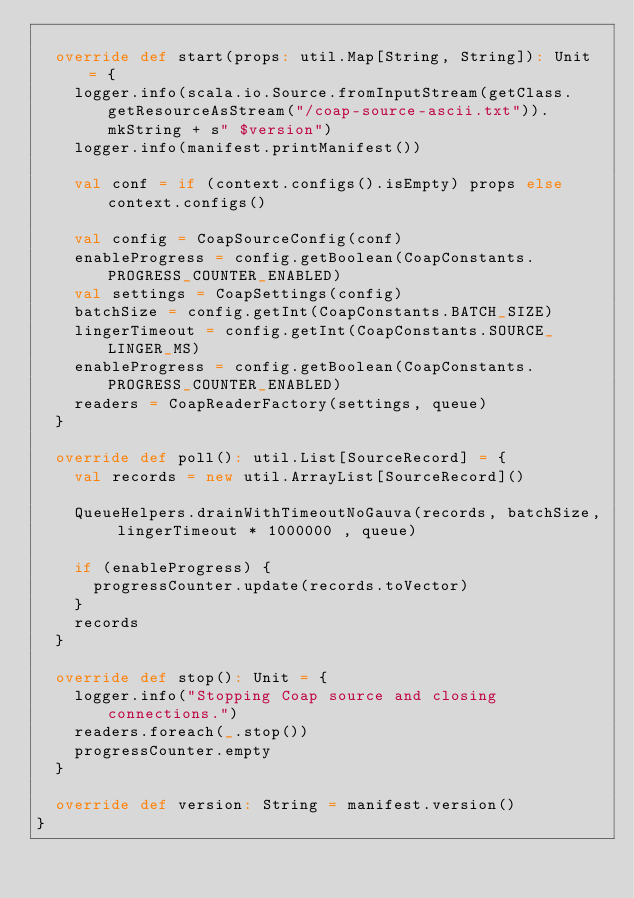<code> <loc_0><loc_0><loc_500><loc_500><_Scala_>
  override def start(props: util.Map[String, String]): Unit = {
    logger.info(scala.io.Source.fromInputStream(getClass.getResourceAsStream("/coap-source-ascii.txt")).mkString + s" $version")
    logger.info(manifest.printManifest())

    val conf = if (context.configs().isEmpty) props else context.configs()

    val config = CoapSourceConfig(conf)
    enableProgress = config.getBoolean(CoapConstants.PROGRESS_COUNTER_ENABLED)
    val settings = CoapSettings(config)
    batchSize = config.getInt(CoapConstants.BATCH_SIZE)
    lingerTimeout = config.getInt(CoapConstants.SOURCE_LINGER_MS)
    enableProgress = config.getBoolean(CoapConstants.PROGRESS_COUNTER_ENABLED)
    readers = CoapReaderFactory(settings, queue)
  }

  override def poll(): util.List[SourceRecord] = {
    val records = new util.ArrayList[SourceRecord]()

    QueueHelpers.drainWithTimeoutNoGauva(records, batchSize, lingerTimeout * 1000000 , queue)

    if (enableProgress) {
      progressCounter.update(records.toVector)
    }
    records
  }

  override def stop(): Unit = {
    logger.info("Stopping Coap source and closing connections.")
    readers.foreach(_.stop())
    progressCounter.empty
  }

  override def version: String = manifest.version()
}
</code> 